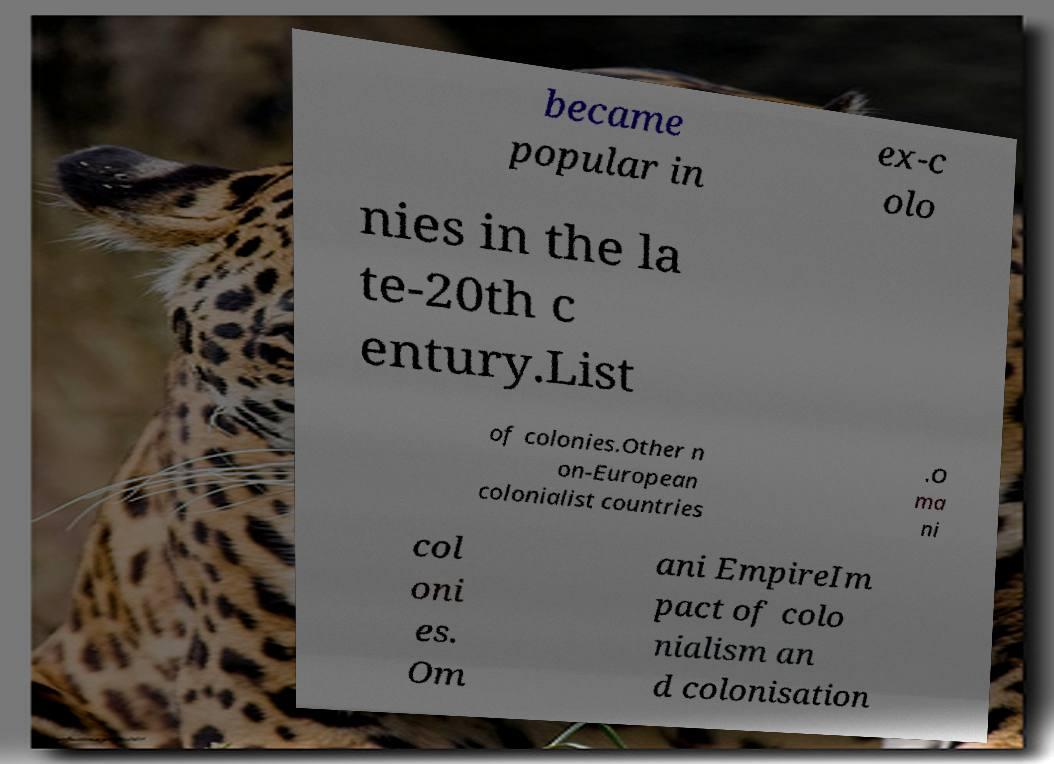I need the written content from this picture converted into text. Can you do that? became popular in ex-c olo nies in the la te-20th c entury.List of colonies.Other n on-European colonialist countries .O ma ni col oni es. Om ani EmpireIm pact of colo nialism an d colonisation 